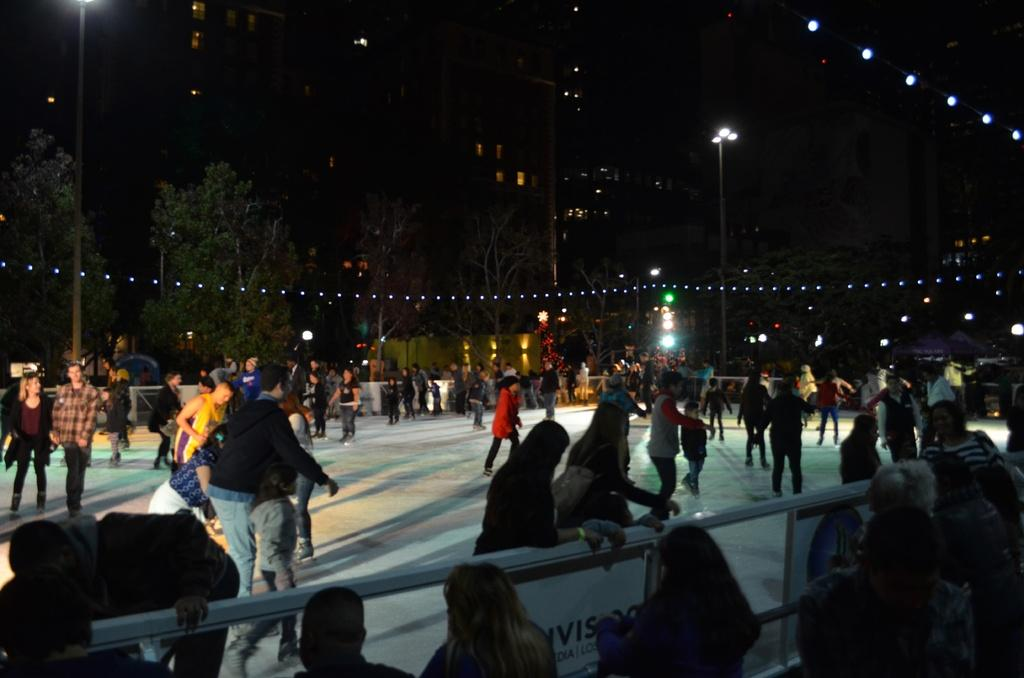What activity are the people in the center of the image engaged in? The people in the center of the image are ice skating. What else can be seen in the image besides the ice skaters? There is a crowd, a fence, trees, poles, buildings, and lights in the background of the image. What might the fence be used for in the image? The fence could be used to separate the ice skating area from the crowd or to provide a barrier for safety. What type of environment is depicted in the background of the image? The background of the image features a mix of natural elements, such as trees, and man-made structures, like poles, buildings, and lights. What scent can be detected coming from the ice skaters in the image? There is no mention of any scent in the image, and it is not possible to determine the scent of the ice skaters based on the visual information provided. 